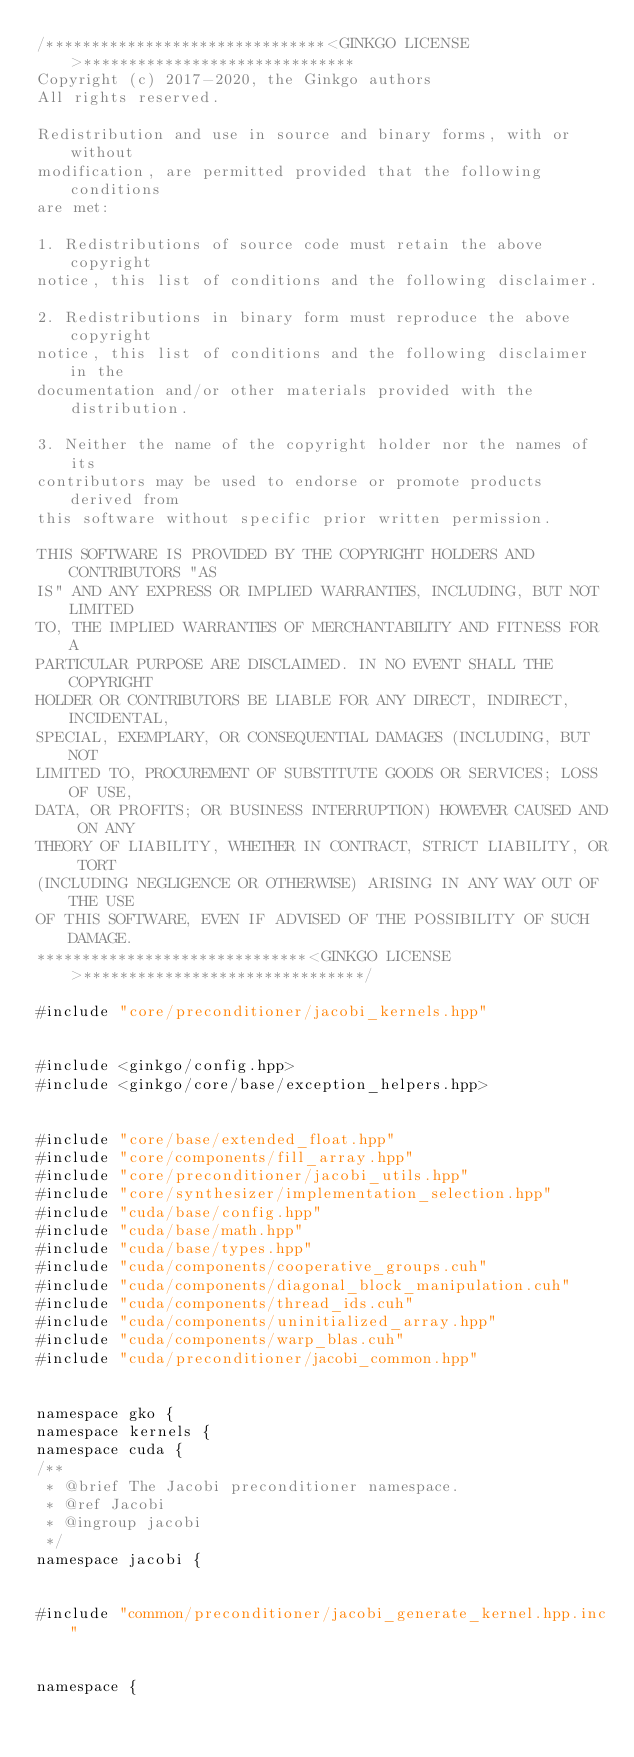Convert code to text. <code><loc_0><loc_0><loc_500><loc_500><_Cuda_>/*******************************<GINKGO LICENSE>******************************
Copyright (c) 2017-2020, the Ginkgo authors
All rights reserved.

Redistribution and use in source and binary forms, with or without
modification, are permitted provided that the following conditions
are met:

1. Redistributions of source code must retain the above copyright
notice, this list of conditions and the following disclaimer.

2. Redistributions in binary form must reproduce the above copyright
notice, this list of conditions and the following disclaimer in the
documentation and/or other materials provided with the distribution.

3. Neither the name of the copyright holder nor the names of its
contributors may be used to endorse or promote products derived from
this software without specific prior written permission.

THIS SOFTWARE IS PROVIDED BY THE COPYRIGHT HOLDERS AND CONTRIBUTORS "AS
IS" AND ANY EXPRESS OR IMPLIED WARRANTIES, INCLUDING, BUT NOT LIMITED
TO, THE IMPLIED WARRANTIES OF MERCHANTABILITY AND FITNESS FOR A
PARTICULAR PURPOSE ARE DISCLAIMED. IN NO EVENT SHALL THE COPYRIGHT
HOLDER OR CONTRIBUTORS BE LIABLE FOR ANY DIRECT, INDIRECT, INCIDENTAL,
SPECIAL, EXEMPLARY, OR CONSEQUENTIAL DAMAGES (INCLUDING, BUT NOT
LIMITED TO, PROCUREMENT OF SUBSTITUTE GOODS OR SERVICES; LOSS OF USE,
DATA, OR PROFITS; OR BUSINESS INTERRUPTION) HOWEVER CAUSED AND ON ANY
THEORY OF LIABILITY, WHETHER IN CONTRACT, STRICT LIABILITY, OR TORT
(INCLUDING NEGLIGENCE OR OTHERWISE) ARISING IN ANY WAY OUT OF THE USE
OF THIS SOFTWARE, EVEN IF ADVISED OF THE POSSIBILITY OF SUCH DAMAGE.
******************************<GINKGO LICENSE>*******************************/

#include "core/preconditioner/jacobi_kernels.hpp"


#include <ginkgo/config.hpp>
#include <ginkgo/core/base/exception_helpers.hpp>


#include "core/base/extended_float.hpp"
#include "core/components/fill_array.hpp"
#include "core/preconditioner/jacobi_utils.hpp"
#include "core/synthesizer/implementation_selection.hpp"
#include "cuda/base/config.hpp"
#include "cuda/base/math.hpp"
#include "cuda/base/types.hpp"
#include "cuda/components/cooperative_groups.cuh"
#include "cuda/components/diagonal_block_manipulation.cuh"
#include "cuda/components/thread_ids.cuh"
#include "cuda/components/uninitialized_array.hpp"
#include "cuda/components/warp_blas.cuh"
#include "cuda/preconditioner/jacobi_common.hpp"


namespace gko {
namespace kernels {
namespace cuda {
/**
 * @brief The Jacobi preconditioner namespace.
 * @ref Jacobi
 * @ingroup jacobi
 */
namespace jacobi {


#include "common/preconditioner/jacobi_generate_kernel.hpp.inc"


namespace {

</code> 